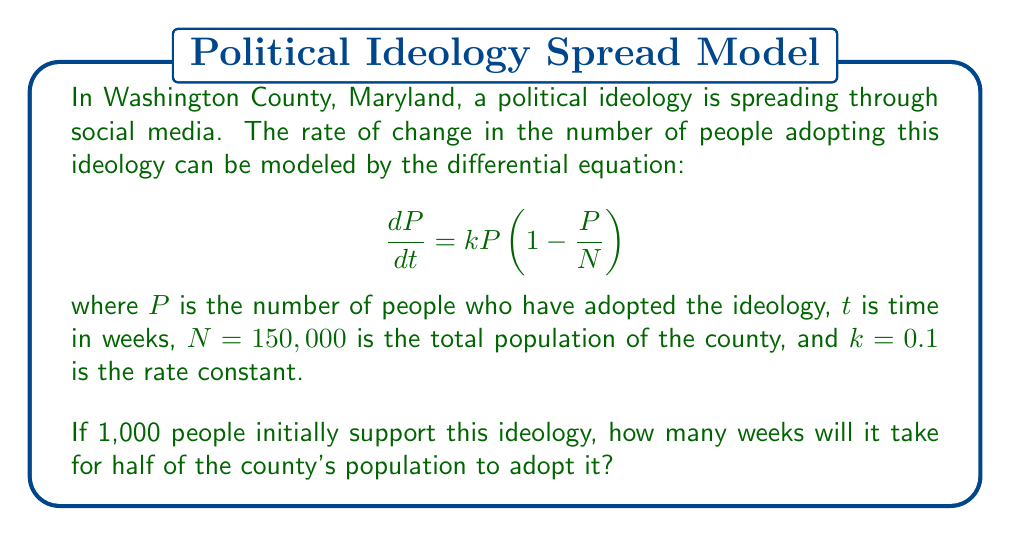Help me with this question. Let's approach this step-by-step:

1) We need to solve the given differential equation, which is a logistic growth model.

2) The solution to this equation is:

   $$P(t) = \frac{N}{1 + (\frac{N}{P_0} - 1)e^{-kt}}$$

   where $P_0$ is the initial population that has adopted the ideology.

3) We're given:
   $N = 150,000$
   $k = 0.1$
   $P_0 = 1,000$

4) We want to find $t$ when $P(t) = N/2 = 75,000$

5) Substituting these values into the equation:

   $$75,000 = \frac{150,000}{1 + (\frac{150,000}{1,000} - 1)e^{-0.1t}}$$

6) Simplifying:

   $$2 = 1 + 149e^{-0.1t}$$
   $$1 = 149e^{-0.1t}$$
   $$\frac{1}{149} = e^{-0.1t}$$

7) Taking natural log of both sides:

   $$\ln(\frac{1}{149}) = -0.1t$$

8) Solving for $t$:

   $$t = -\frac{\ln(\frac{1}{149})}{0.1} = \frac{\ln(149)}{0.1} \approx 50.1$$

Therefore, it will take approximately 50.1 weeks for half of the county's population to adopt the ideology.
Answer: 50.1 weeks 